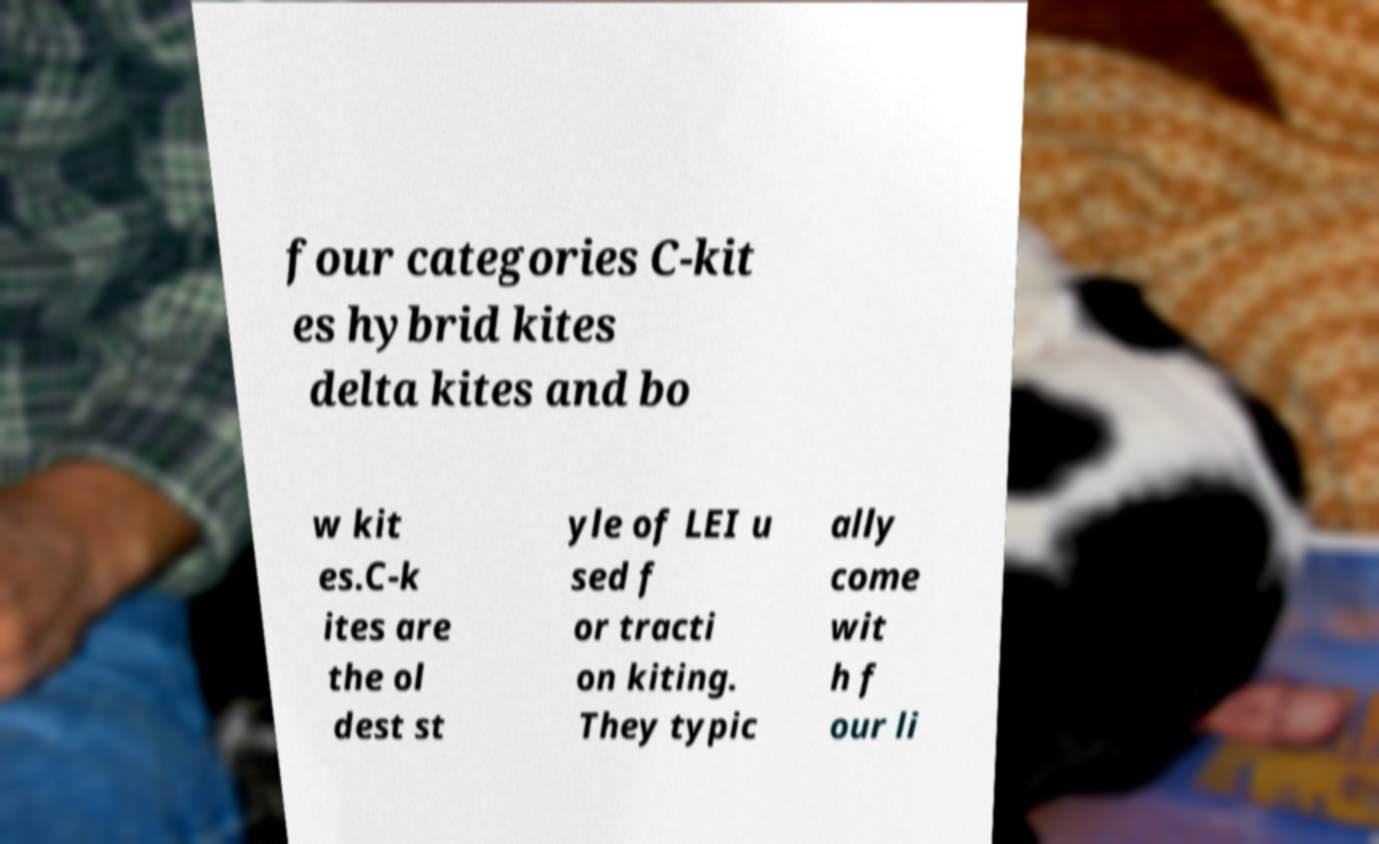Please read and relay the text visible in this image. What does it say? four categories C-kit es hybrid kites delta kites and bo w kit es.C-k ites are the ol dest st yle of LEI u sed f or tracti on kiting. They typic ally come wit h f our li 